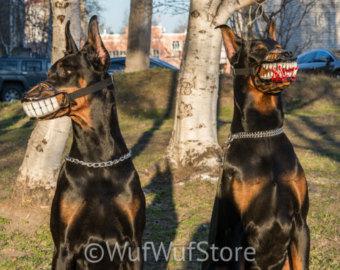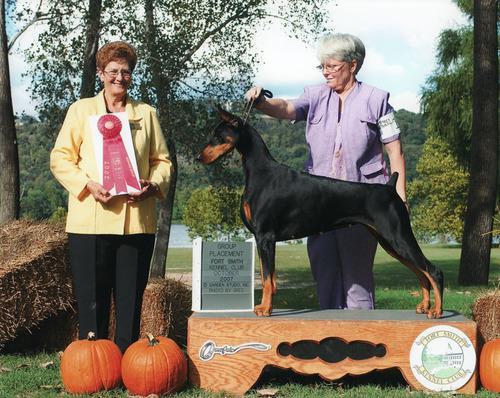The first image is the image on the left, the second image is the image on the right. Assess this claim about the two images: "One doberman has its front paws on a fence.". Correct or not? Answer yes or no. No. The first image is the image on the left, the second image is the image on the right. Given the left and right images, does the statement "One image features a doberman with its front paws over the edge of a wooden fence." hold true? Answer yes or no. No. 